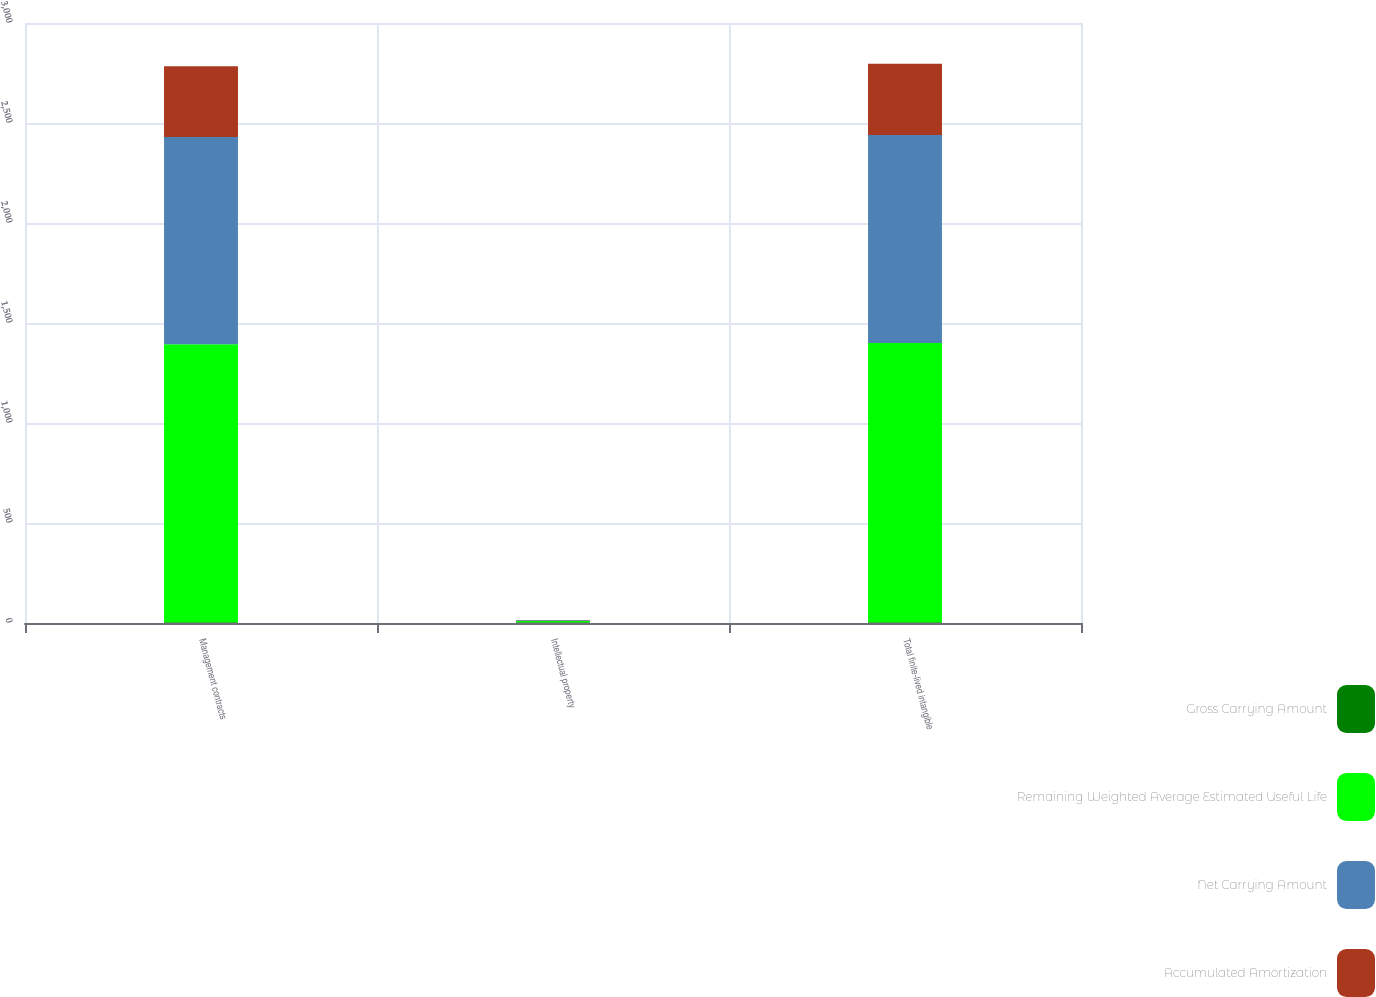Convert chart. <chart><loc_0><loc_0><loc_500><loc_500><stacked_bar_chart><ecel><fcel>Management contracts<fcel>Intellectual property<fcel>Total finite-lived intangible<nl><fcel>Gross Carrying Amount<fcel>3.8<fcel>3.6<fcel>3.8<nl><fcel>Remaining Weighted Average Estimated Useful Life<fcel>1390<fcel>6<fcel>1396<nl><fcel>Net Carrying Amount<fcel>1036<fcel>4<fcel>1040<nl><fcel>Accumulated Amortization<fcel>354<fcel>2<fcel>356<nl></chart> 